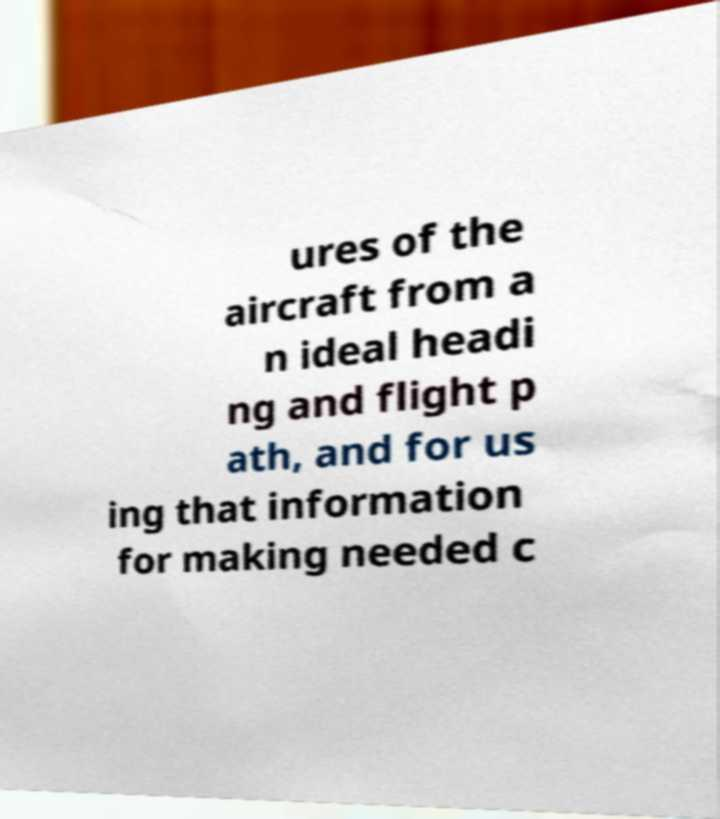Can you accurately transcribe the text from the provided image for me? ures of the aircraft from a n ideal headi ng and flight p ath, and for us ing that information for making needed c 